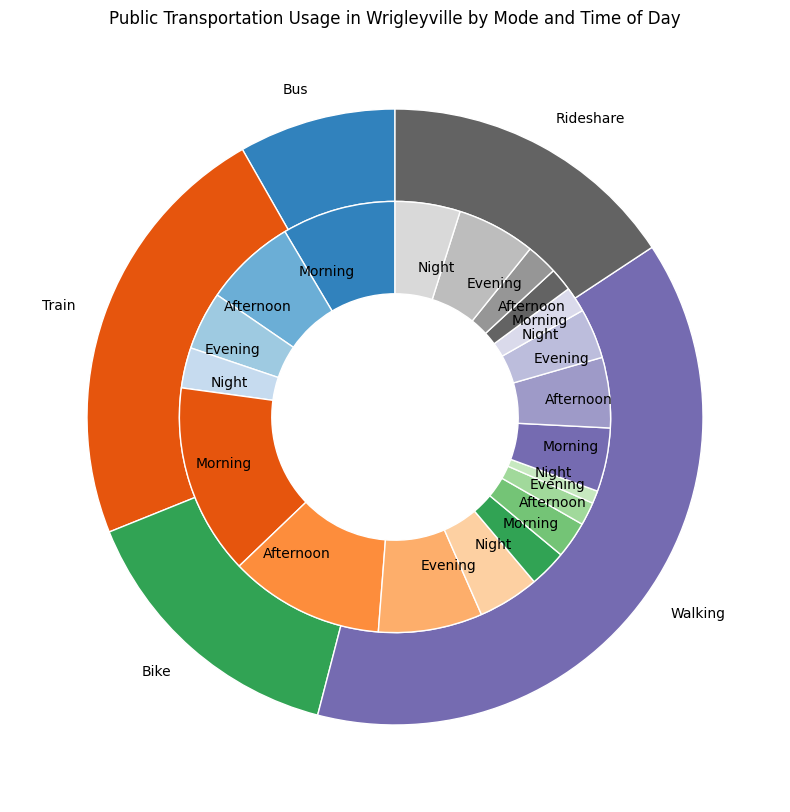What percentage of public transportation usage is by Train in the Evening? Locate the "Train" segment in the outer pie chart and then identify the "Evening" segment within the inner pie chart. The percentage is shown next to it.
Answer: 13.9% Which time of day has the highest public transportation usage for the Bus mode? Compare the inner segments for the "Bus" section of the outer pie chart to find the highest percentage. Morning has the highest usage for the Bus mode.
Answer: Morning What is the total percentage of public transportation usage occurring at Night for all modes combined? Sum the percentage values for "Night" from all modes: Bus (5.4), Train (8.2), Bike (1.7), Walking (3.4), and Rideshare (8.7). 5.4 + 8.2 + 1.7 + 3.4 + 8.7 = 27.4%
Answer: 27.4% Between Train and Walking, which mode has a higher usage in the Afternoon? Compare the percentage values for the Afternoon usage in the Train and Walking segments. Train has 20.7%, and Walking has 9.4%; Train is higher.
Answer: Train Which mode experiences the lowest percentage of usage in the Morning? Compare the percentage values for Morning across all modes: Bus (15.2), Train (25.5), Bike (5.0), Walking (8.5), and Rideshare (3.1). Rideshare has the lowest percentage.
Answer: Rideshare How much higher is the percentage of Train usage in the Morning compared to Evening? Subtract the percentage of Train usage in the Evening from the Morning. 25.5 - 13.9 = 11.6%
Answer: 11.6% What is the difference in percentage between Rideshare usage in the Night and Bus usage in the Night? Subtract the percentage of Bus usage in the Night from the Rideshare usage in the Night. 8.7 - 5.4 = 3.3%
Answer: 3.3% What is the most used mode of transportation in the Evening? Identify the inner segment with the highest percentage under the Evening time of day. Rideshare at 10.5% has the highest use.
Answer: Rideshare 